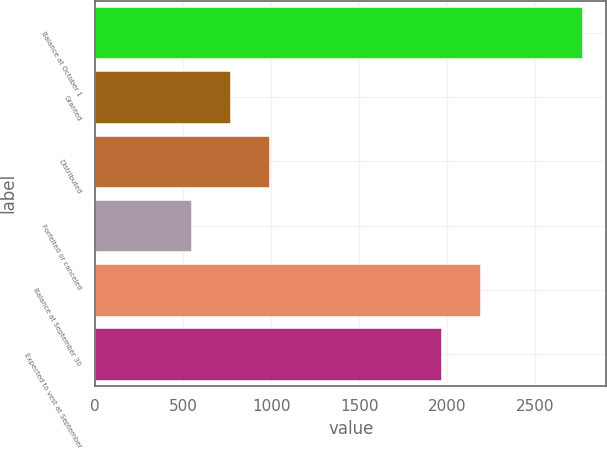Convert chart to OTSL. <chart><loc_0><loc_0><loc_500><loc_500><bar_chart><fcel>Balance at October 1<fcel>Granted<fcel>Distributed<fcel>Forfeited or canceled<fcel>Balance at September 30<fcel>Expected to vest at September<nl><fcel>2765<fcel>767.9<fcel>989.8<fcel>546<fcel>2185.9<fcel>1964<nl></chart> 